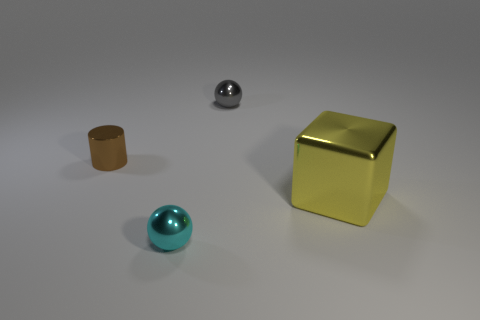Add 4 brown metal things. How many objects exist? 8 Subtract all blocks. How many objects are left? 3 Add 3 large cubes. How many large cubes exist? 4 Subtract 0 cyan cylinders. How many objects are left? 4 Subtract all large green blocks. Subtract all tiny cyan metal balls. How many objects are left? 3 Add 1 large shiny cubes. How many large shiny cubes are left? 2 